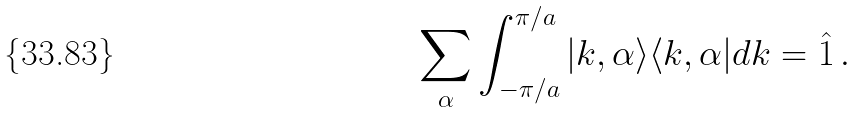Convert formula to latex. <formula><loc_0><loc_0><loc_500><loc_500>\sum _ { \alpha } \int _ { - \pi / a } ^ { \pi / a } | k , \alpha \rangle \langle k , \alpha | d k = \hat { 1 } \, .</formula> 